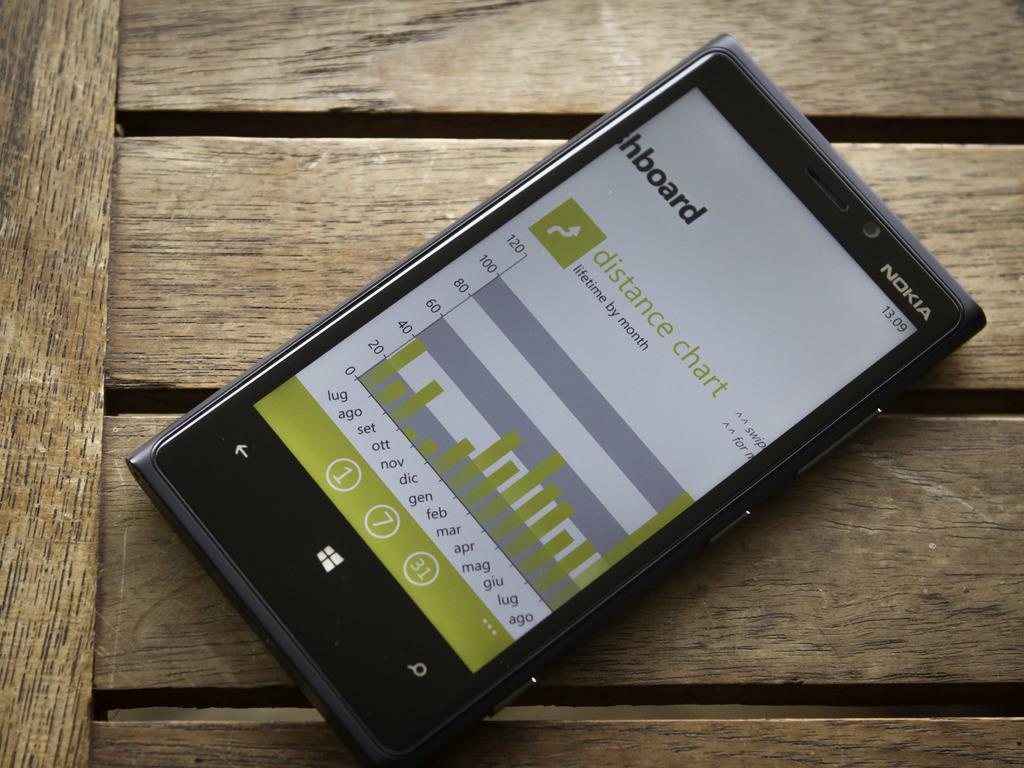<image>
Describe the image concisely. a Nokia cell phone with a screen on HBOARD with a graph 